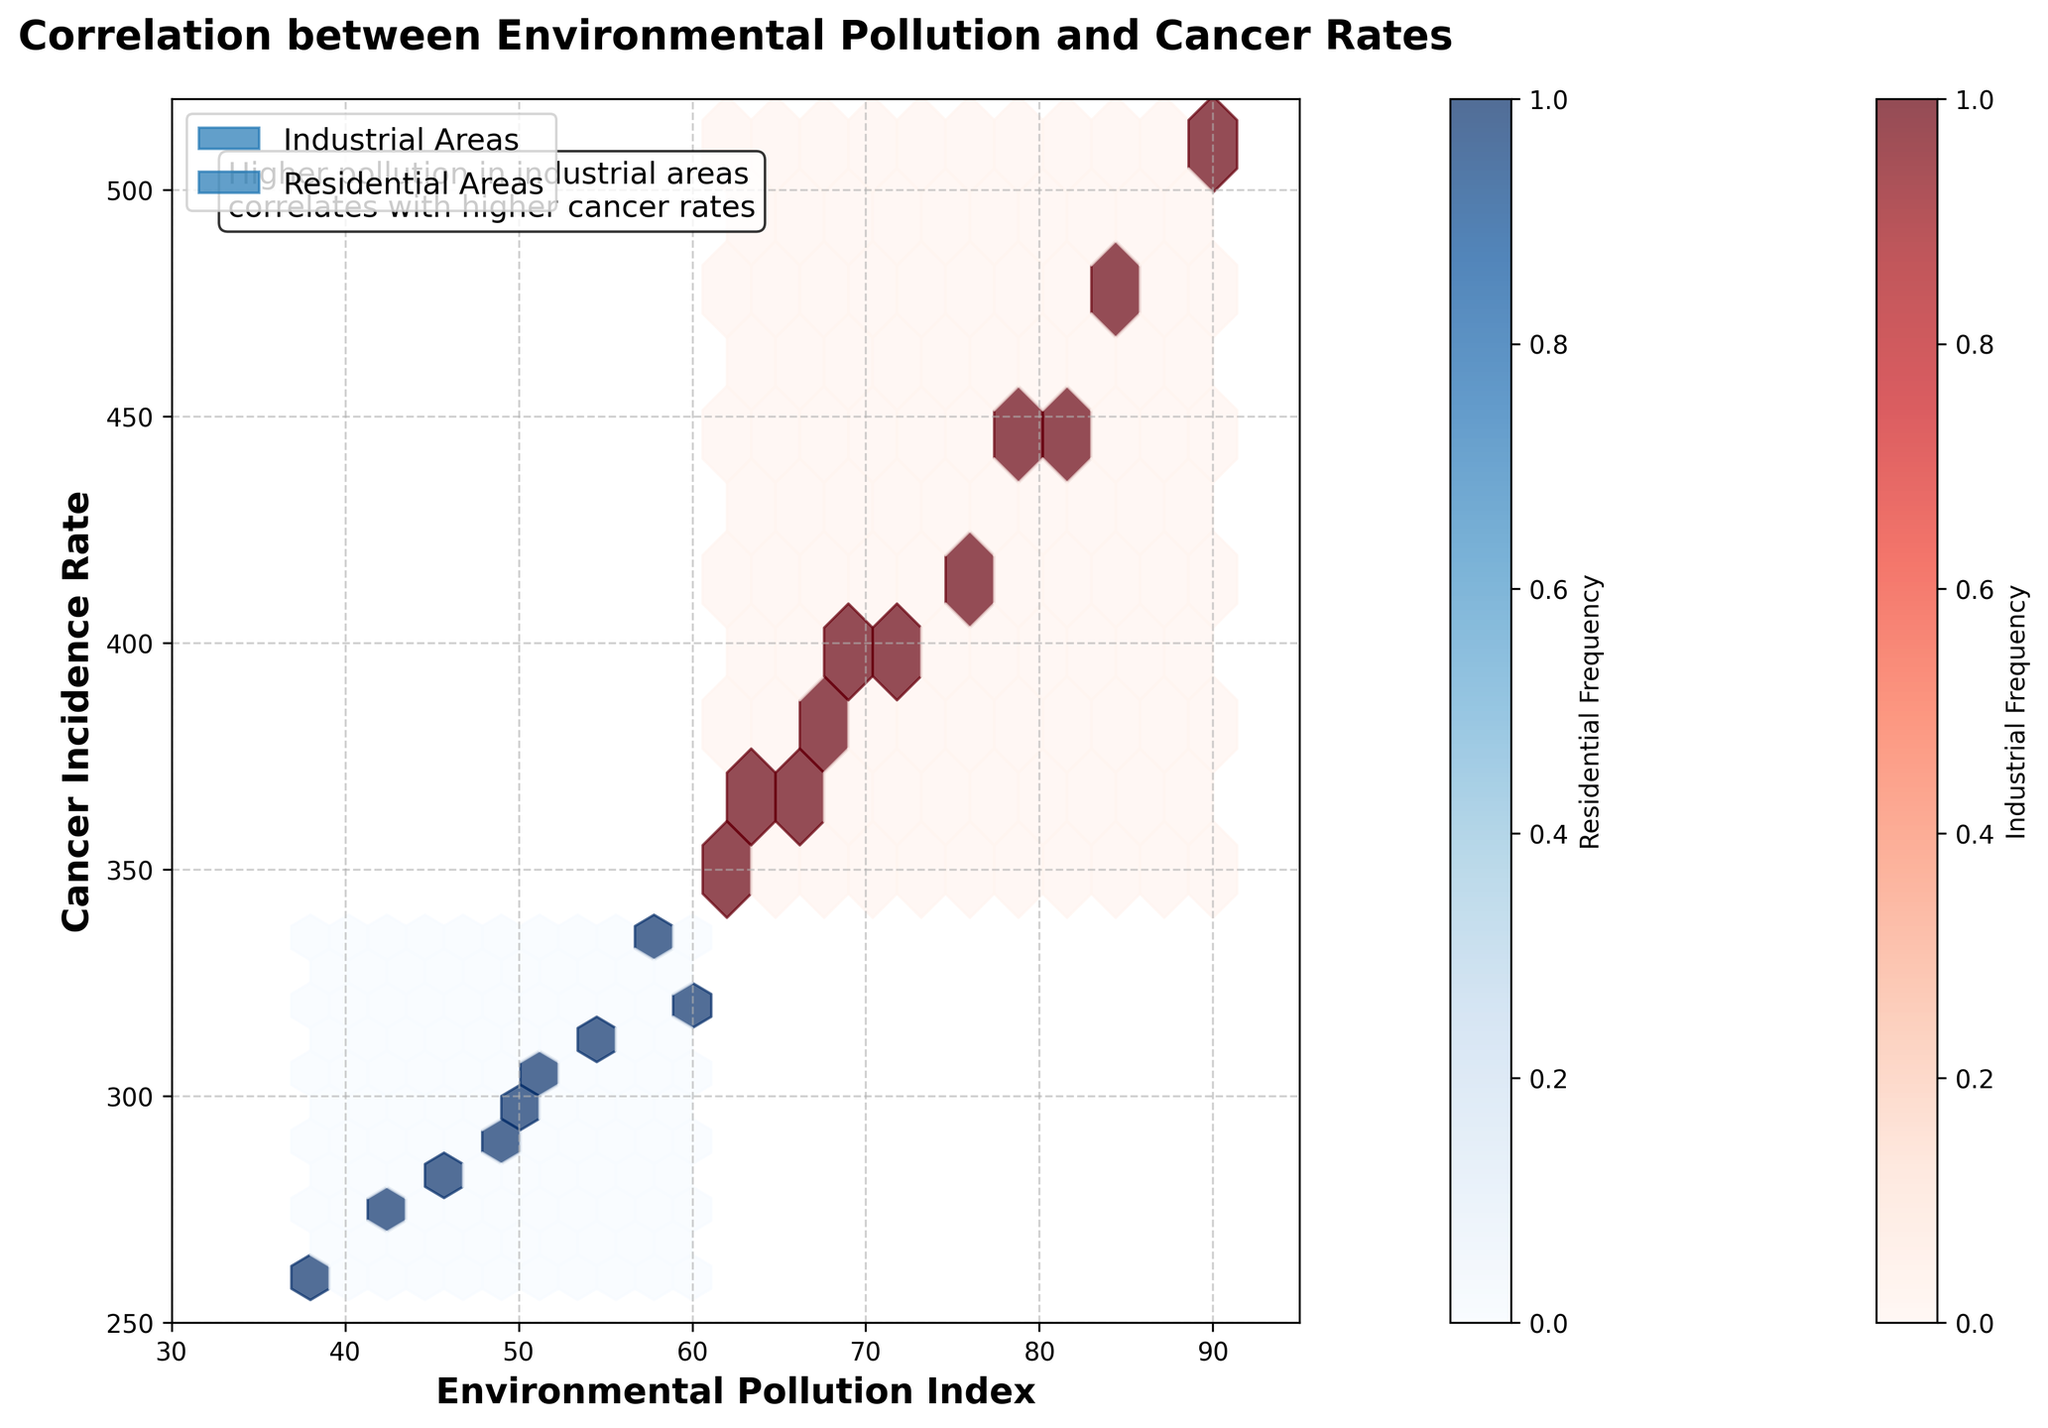What's the title of the figure? The title of the figure can be found at the top of the plot.
Answer: Correlation between Environmental Pollution and Cancer Rates What are the labels on the x-axis and y-axis? The labels on the x-axis and y-axis can be located at the bottom and left side of the plot, respectively.
Answer: Environmental Pollution Index, Cancer Incidence Rate What colors represent industrial and residential areas in the plot? The colors can be identified by looking at the hexagon colors in the plot and matching them with the colorbar labels.
Answer: Reds for Industrial areas, Blues for Residential areas What’s the general trend observed in Industrial areas? Observing the hexbin distribution for industrial areas, which is represented by red hexagons, will show the pattern.
Answer: Higher environmental pollution correlates with higher cancer rates At what environmental pollution index do you see the highest cancer incidence rate in industrial areas? Look for the highest y-value among the red hexagons and note the corresponding x-value.
Answer: Around 90 How do cancer incidence rates compare between industrial and residential areas at an environmental pollution index of 60? Compare the hexbin densities or color intensities for both areas at the same x-value.
Answer: Higher in Industrial areas What are the axis limits set for the plot? The axis limits are observed at the edges of the plot along both x and y axes.
Answer: 30 to 95 for x-axis, 250 to 520 for y-axis Are there any data points for residential areas at environmental pollution index above 70? Observe the blue hexagons to see if any exist beyond the 70 mark on the x-axis.
Answer: No What are the frequencies represented in the color bars for industrial and residential areas? Locate the color bars on the plot and read the labels next to them.
Answer: Industrial Frequency, Residential Frequency Can you identify a correlation trend in residential areas based on pollution levels and cancer rates? Look at the blue hexagons pattern; identifying if there is a consistent rise or fall in cancer rates with pollution levels.
Answer: Generally lower pollution correlates with lower cancer rates 